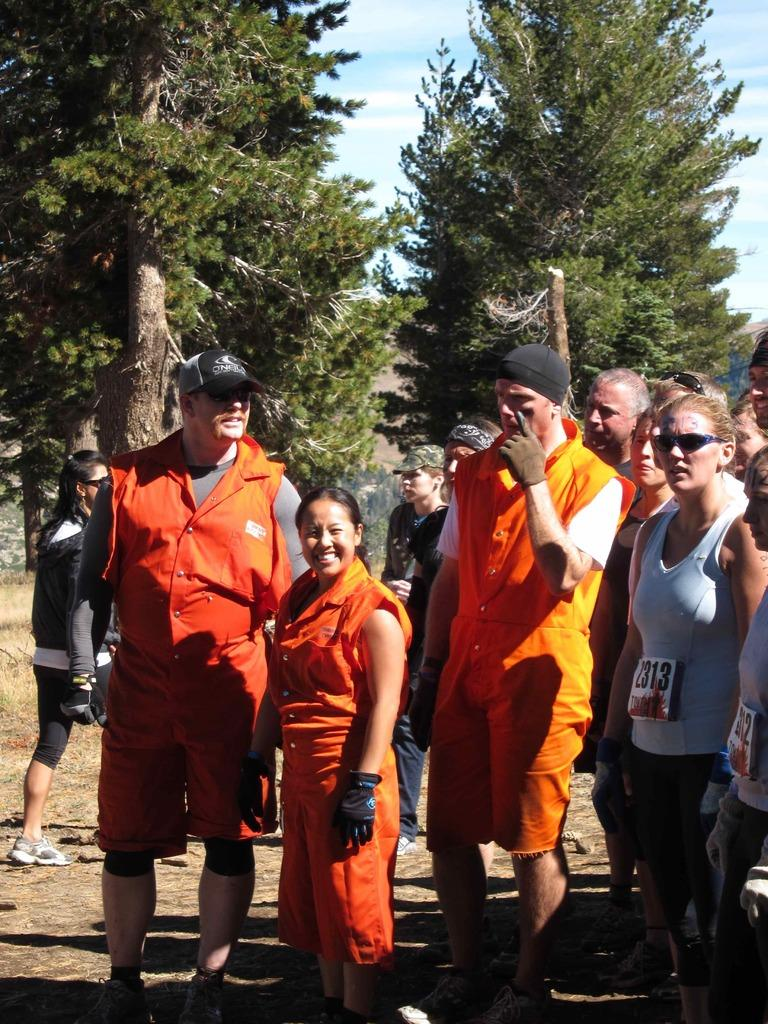What is the main subject of the image? The main subject of the image is a group of people. What are the people in the image doing? The people are standing. What are the people wearing in the image? The people are wearing clothes. What can be seen in the middle of the image? There are trees in the middle of the image. What is visible at the top of the image? The sky is visible at the top of the image. What type of plot is being discussed by the committee in the image? There is no committee or plot present in the image; it features a group of people standing with trees and the sky visible. 